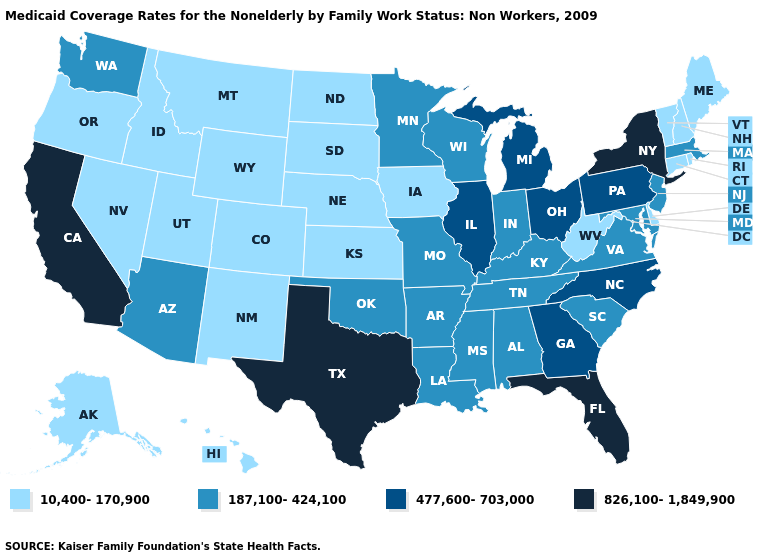Does New York have the highest value in the Northeast?
Quick response, please. Yes. Name the states that have a value in the range 187,100-424,100?
Quick response, please. Alabama, Arizona, Arkansas, Indiana, Kentucky, Louisiana, Maryland, Massachusetts, Minnesota, Mississippi, Missouri, New Jersey, Oklahoma, South Carolina, Tennessee, Virginia, Washington, Wisconsin. What is the lowest value in the USA?
Short answer required. 10,400-170,900. What is the value of Louisiana?
Short answer required. 187,100-424,100. Among the states that border Oregon , does Washington have the lowest value?
Write a very short answer. No. Among the states that border Maryland , which have the lowest value?
Answer briefly. Delaware, West Virginia. Name the states that have a value in the range 477,600-703,000?
Short answer required. Georgia, Illinois, Michigan, North Carolina, Ohio, Pennsylvania. What is the highest value in the USA?
Write a very short answer. 826,100-1,849,900. How many symbols are there in the legend?
Concise answer only. 4. Does Florida have a lower value than New Jersey?
Give a very brief answer. No. What is the value of New Mexico?
Answer briefly. 10,400-170,900. What is the value of New Jersey?
Answer briefly. 187,100-424,100. Name the states that have a value in the range 826,100-1,849,900?
Give a very brief answer. California, Florida, New York, Texas. Is the legend a continuous bar?
Be succinct. No. What is the value of Colorado?
Short answer required. 10,400-170,900. 